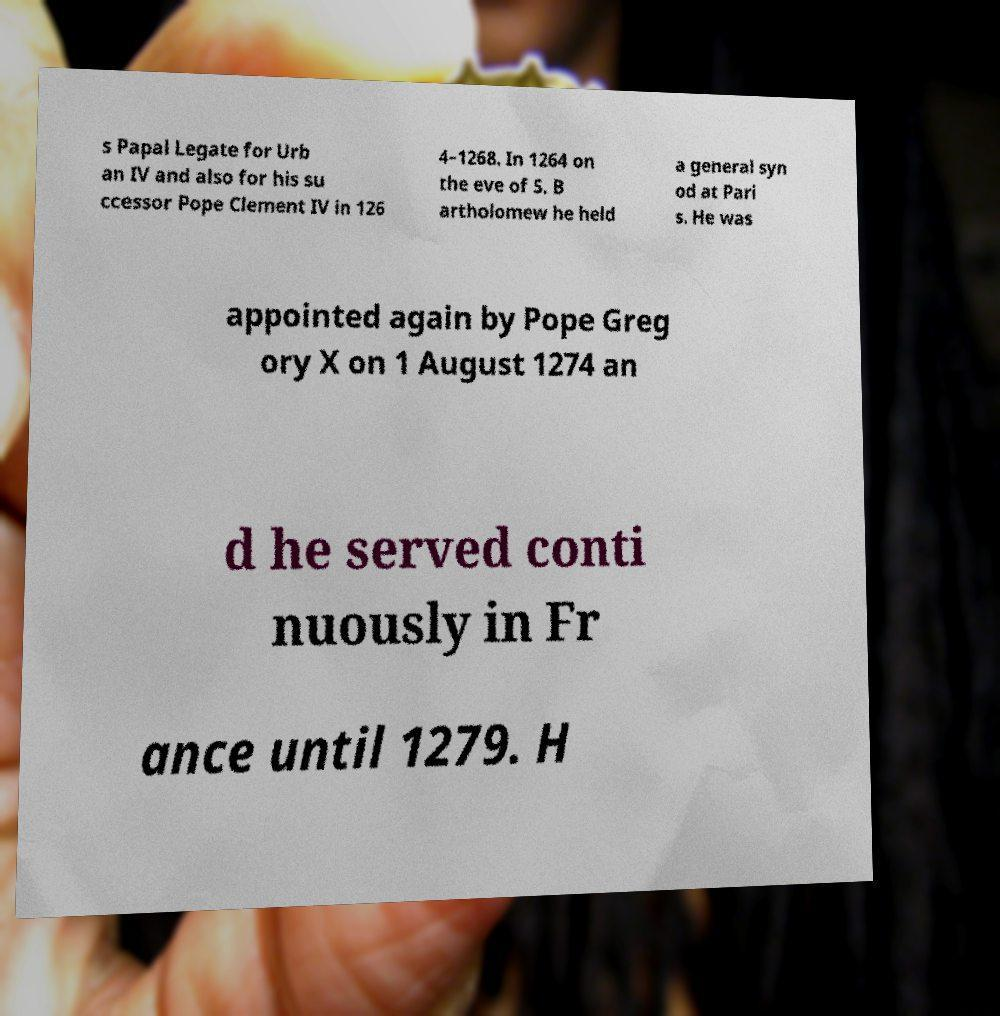Please read and relay the text visible in this image. What does it say? s Papal Legate for Urb an IV and also for his su ccessor Pope Clement IV in 126 4–1268. In 1264 on the eve of S. B artholomew he held a general syn od at Pari s. He was appointed again by Pope Greg ory X on 1 August 1274 an d he served conti nuously in Fr ance until 1279. H 